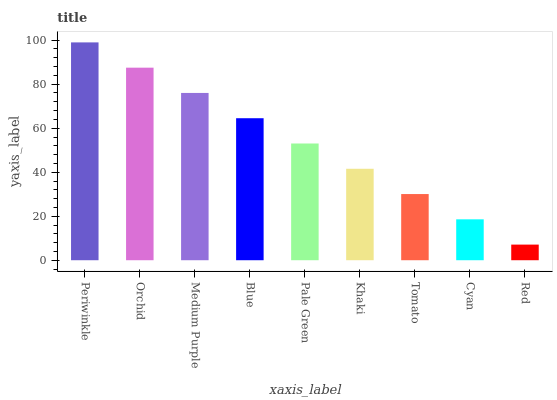Is Orchid the minimum?
Answer yes or no. No. Is Orchid the maximum?
Answer yes or no. No. Is Periwinkle greater than Orchid?
Answer yes or no. Yes. Is Orchid less than Periwinkle?
Answer yes or no. Yes. Is Orchid greater than Periwinkle?
Answer yes or no. No. Is Periwinkle less than Orchid?
Answer yes or no. No. Is Pale Green the high median?
Answer yes or no. Yes. Is Pale Green the low median?
Answer yes or no. Yes. Is Orchid the high median?
Answer yes or no. No. Is Blue the low median?
Answer yes or no. No. 